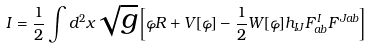<formula> <loc_0><loc_0><loc_500><loc_500>I = \frac { 1 } { 2 } \int d ^ { 2 } x \sqrt { g } \left [ \varphi R + V [ \varphi ] - \frac { 1 } { 2 } W [ \varphi ] h _ { I J } F ^ { I } _ { a b } F ^ { J a b } \right ]</formula> 